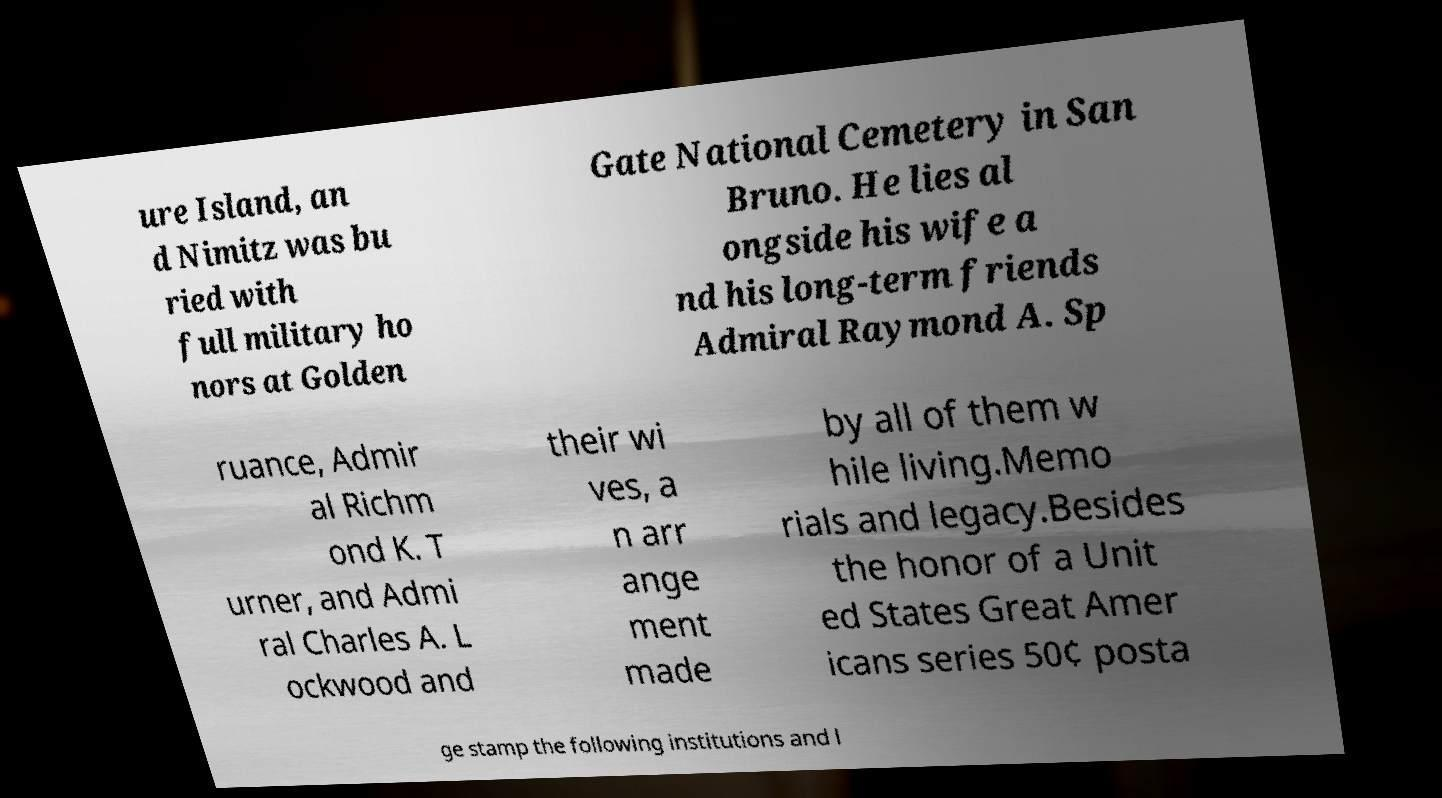For documentation purposes, I need the text within this image transcribed. Could you provide that? ure Island, an d Nimitz was bu ried with full military ho nors at Golden Gate National Cemetery in San Bruno. He lies al ongside his wife a nd his long-term friends Admiral Raymond A. Sp ruance, Admir al Richm ond K. T urner, and Admi ral Charles A. L ockwood and their wi ves, a n arr ange ment made by all of them w hile living.Memo rials and legacy.Besides the honor of a Unit ed States Great Amer icans series 50¢ posta ge stamp the following institutions and l 